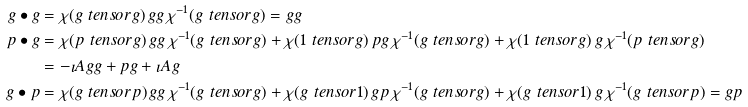<formula> <loc_0><loc_0><loc_500><loc_500>g \bullet g & = \chi ( g \ t e n s o r g ) \, g g \, \chi ^ { - 1 } ( g \ t e n s o r g ) = g g \\ p \bullet g & = \chi ( p \ t e n s o r g ) \, g g \, \chi ^ { - 1 } ( g \ t e n s o r g ) + \chi ( 1 \ t e n s o r g ) \, p g \, \chi ^ { - 1 } ( g \ t e n s o r g ) + \chi ( 1 \ t e n s o r g ) \, g \, \chi ^ { - 1 } ( p \ t e n s o r g ) \\ & = - \imath A g g + p g + \imath A g \\ g \bullet p & = \chi ( g \ t e n s o r p ) \, g g \, \chi ^ { - 1 } ( g \ t e n s o r g ) + \chi ( g \ t e n s o r 1 ) \, g p \, \chi ^ { - 1 } ( g \ t e n s o r g ) + \chi ( g \ t e n s o r 1 ) \, g \, \chi ^ { - 1 } ( g \ t e n s o r p ) = g p</formula> 